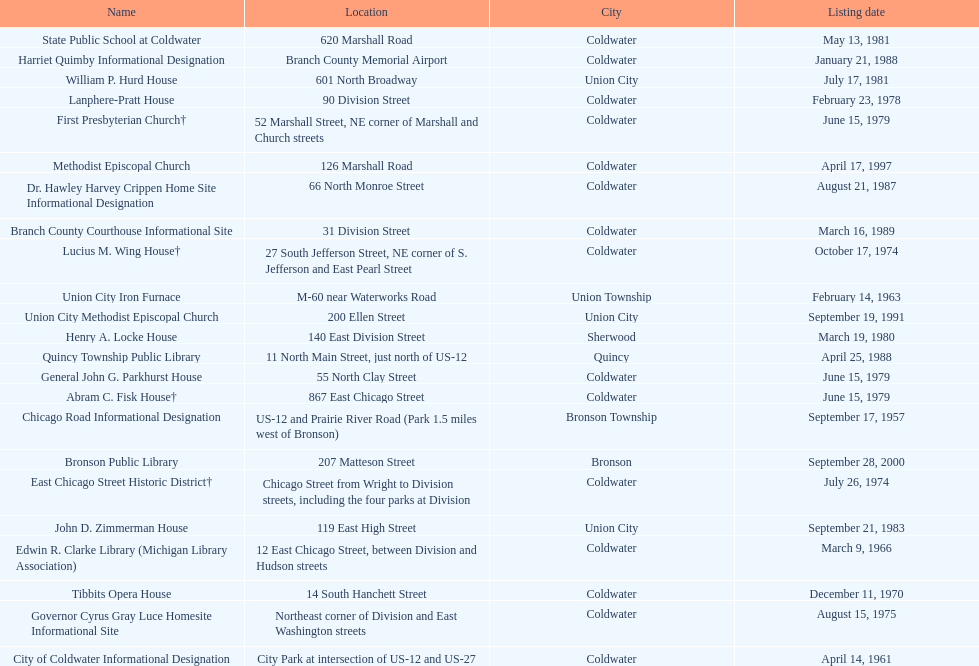How many historic places were documented before 1965? 3. 